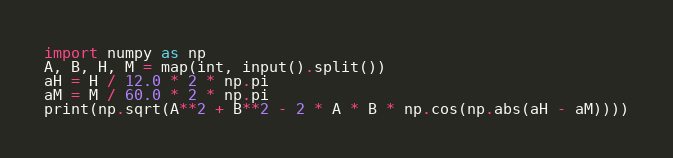<code> <loc_0><loc_0><loc_500><loc_500><_Python_>import numpy as np
A, B, H, M = map(int, input().split())
aH = H / 12.0 * 2 * np.pi
aM = M / 60.0 * 2 * np.pi
print(np.sqrt(A**2 + B**2 - 2 * A * B * np.cos(np.abs(aH - aM))))
</code> 